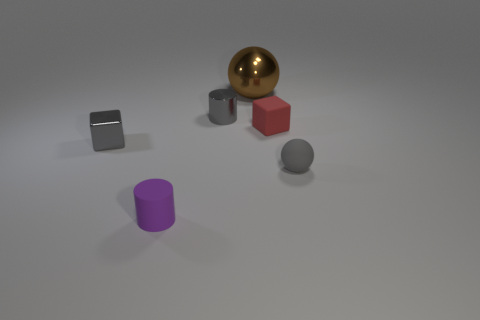Subtract all purple cubes. Subtract all purple spheres. How many cubes are left? 2 Add 2 big brown metallic things. How many objects exist? 8 Subtract all cylinders. How many objects are left? 4 Subtract 0 blue spheres. How many objects are left? 6 Subtract all tiny purple things. Subtract all large brown rubber spheres. How many objects are left? 5 Add 2 tiny gray rubber spheres. How many tiny gray rubber spheres are left? 3 Add 5 cyan shiny objects. How many cyan shiny objects exist? 5 